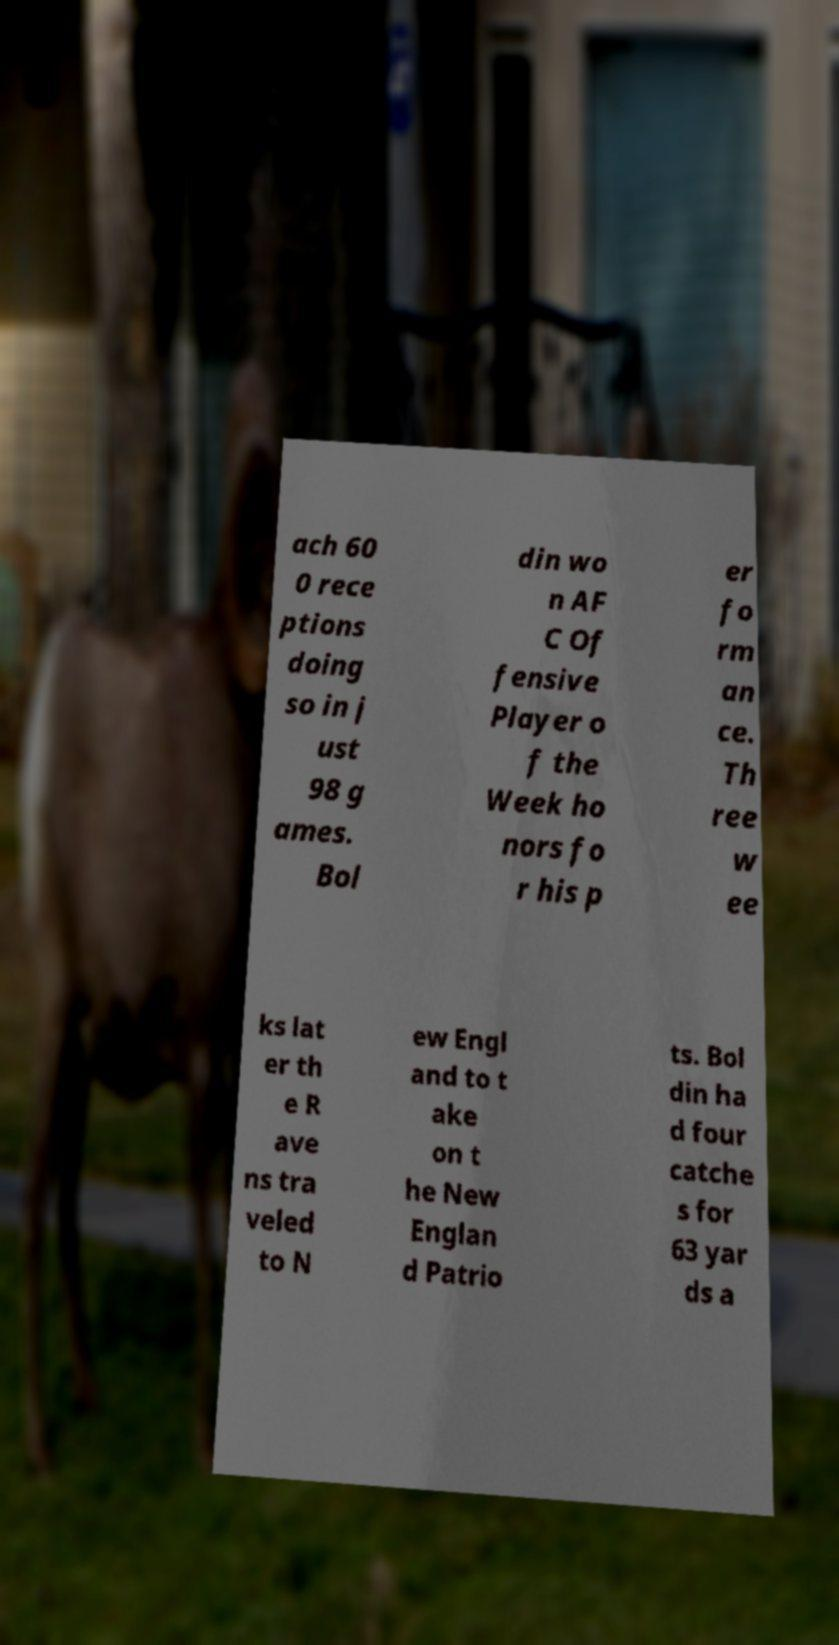What messages or text are displayed in this image? I need them in a readable, typed format. ach 60 0 rece ptions doing so in j ust 98 g ames. Bol din wo n AF C Of fensive Player o f the Week ho nors fo r his p er fo rm an ce. Th ree w ee ks lat er th e R ave ns tra veled to N ew Engl and to t ake on t he New Englan d Patrio ts. Bol din ha d four catche s for 63 yar ds a 